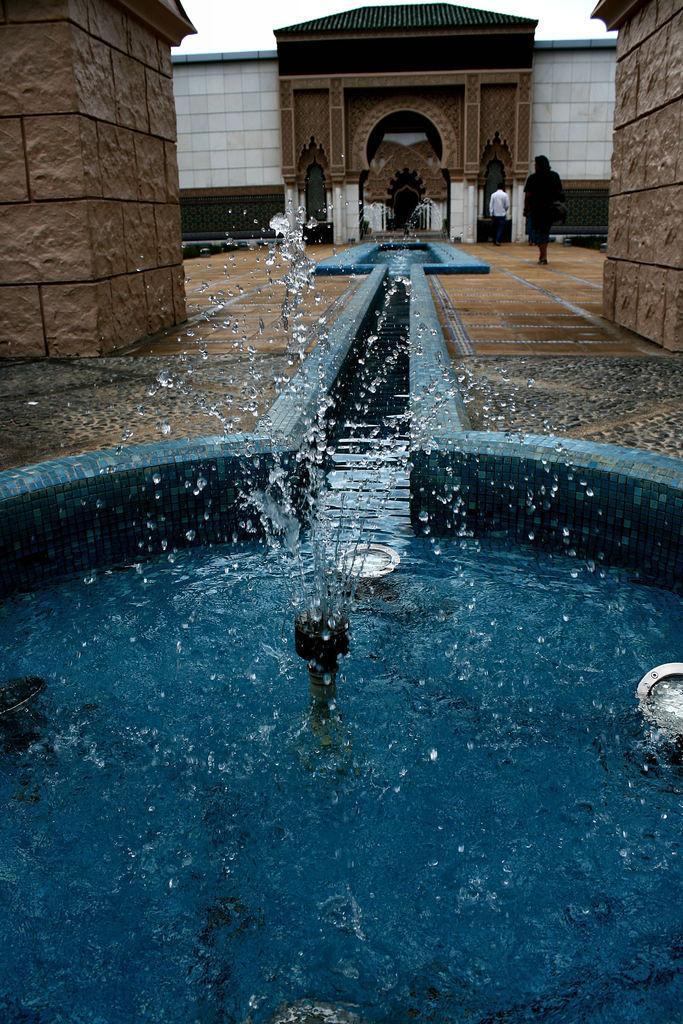Please provide a concise description of this image. This image is taken outdoors. At the bottom of the image there is a fountain with water. In the background there is a building with a few walls and a door. Two men are walking on the floor. 